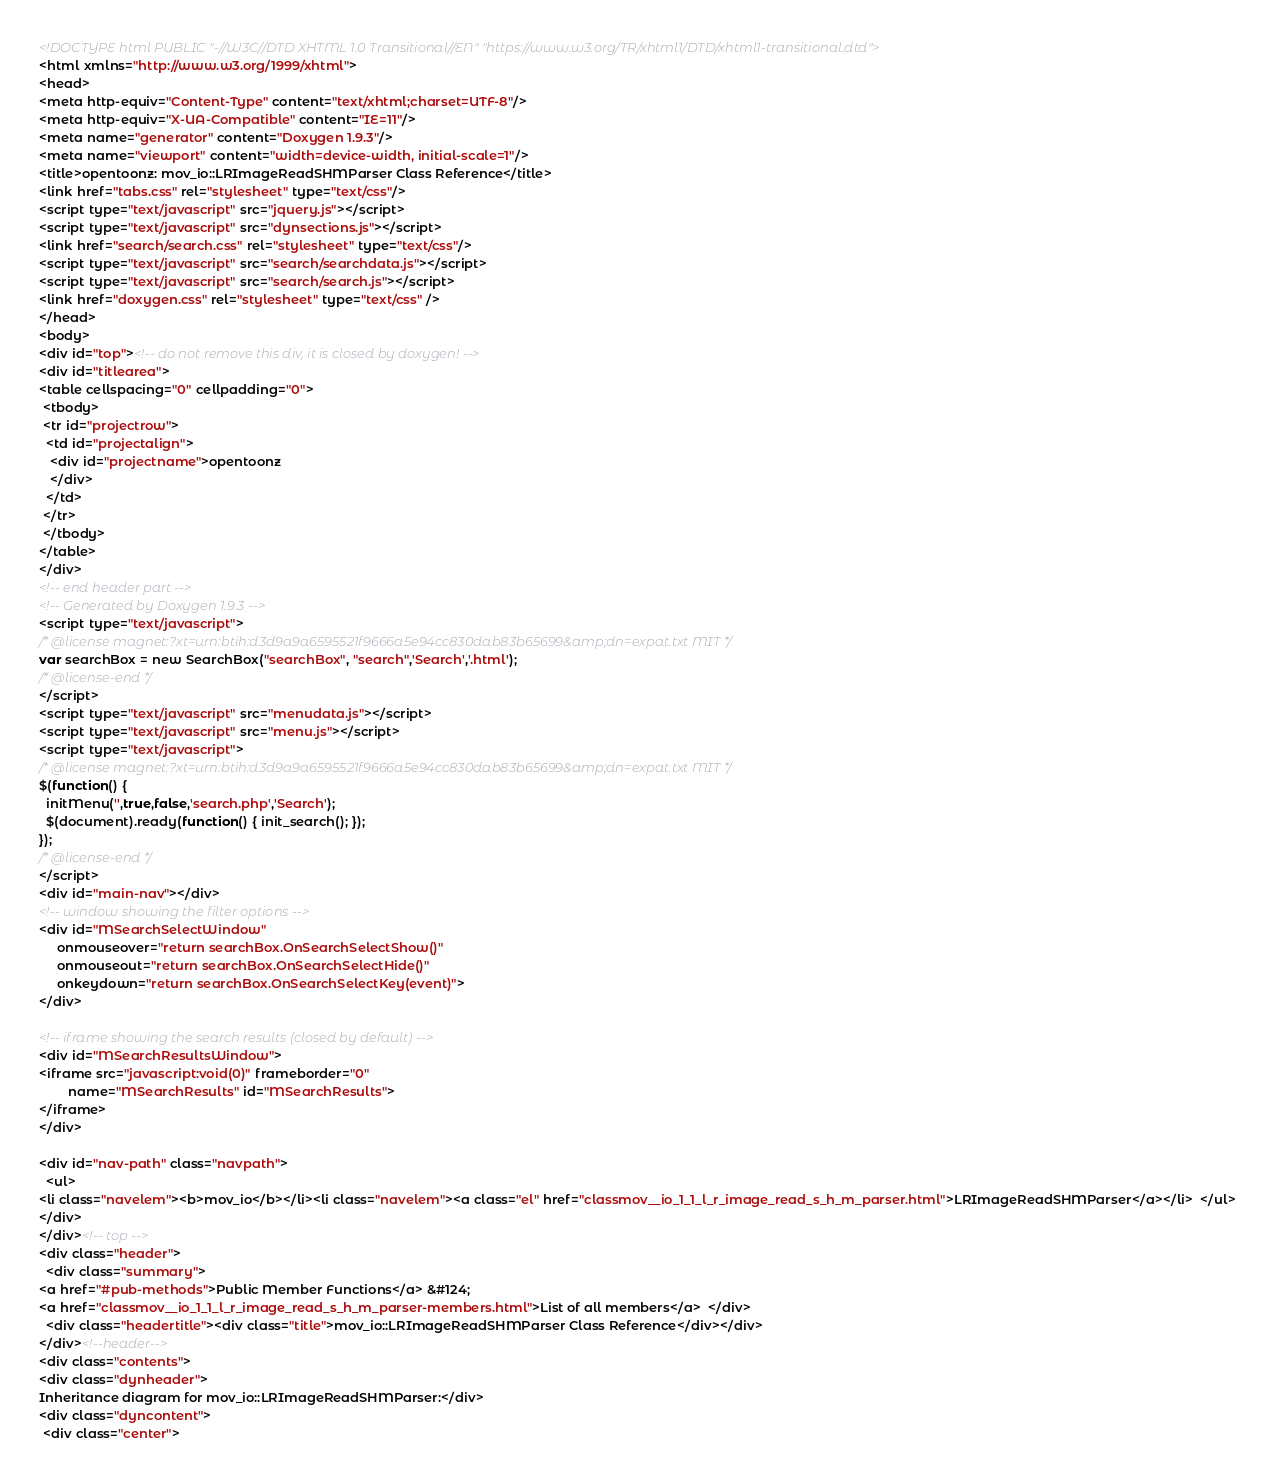Convert code to text. <code><loc_0><loc_0><loc_500><loc_500><_HTML_><!DOCTYPE html PUBLIC "-//W3C//DTD XHTML 1.0 Transitional//EN" "https://www.w3.org/TR/xhtml1/DTD/xhtml1-transitional.dtd">
<html xmlns="http://www.w3.org/1999/xhtml">
<head>
<meta http-equiv="Content-Type" content="text/xhtml;charset=UTF-8"/>
<meta http-equiv="X-UA-Compatible" content="IE=11"/>
<meta name="generator" content="Doxygen 1.9.3"/>
<meta name="viewport" content="width=device-width, initial-scale=1"/>
<title>opentoonz: mov_io::LRImageReadSHMParser Class Reference</title>
<link href="tabs.css" rel="stylesheet" type="text/css"/>
<script type="text/javascript" src="jquery.js"></script>
<script type="text/javascript" src="dynsections.js"></script>
<link href="search/search.css" rel="stylesheet" type="text/css"/>
<script type="text/javascript" src="search/searchdata.js"></script>
<script type="text/javascript" src="search/search.js"></script>
<link href="doxygen.css" rel="stylesheet" type="text/css" />
</head>
<body>
<div id="top"><!-- do not remove this div, it is closed by doxygen! -->
<div id="titlearea">
<table cellspacing="0" cellpadding="0">
 <tbody>
 <tr id="projectrow">
  <td id="projectalign">
   <div id="projectname">opentoonz
   </div>
  </td>
 </tr>
 </tbody>
</table>
</div>
<!-- end header part -->
<!-- Generated by Doxygen 1.9.3 -->
<script type="text/javascript">
/* @license magnet:?xt=urn:btih:d3d9a9a6595521f9666a5e94cc830dab83b65699&amp;dn=expat.txt MIT */
var searchBox = new SearchBox("searchBox", "search",'Search','.html');
/* @license-end */
</script>
<script type="text/javascript" src="menudata.js"></script>
<script type="text/javascript" src="menu.js"></script>
<script type="text/javascript">
/* @license magnet:?xt=urn:btih:d3d9a9a6595521f9666a5e94cc830dab83b65699&amp;dn=expat.txt MIT */
$(function() {
  initMenu('',true,false,'search.php','Search');
  $(document).ready(function() { init_search(); });
});
/* @license-end */
</script>
<div id="main-nav"></div>
<!-- window showing the filter options -->
<div id="MSearchSelectWindow"
     onmouseover="return searchBox.OnSearchSelectShow()"
     onmouseout="return searchBox.OnSearchSelectHide()"
     onkeydown="return searchBox.OnSearchSelectKey(event)">
</div>

<!-- iframe showing the search results (closed by default) -->
<div id="MSearchResultsWindow">
<iframe src="javascript:void(0)" frameborder="0" 
        name="MSearchResults" id="MSearchResults">
</iframe>
</div>

<div id="nav-path" class="navpath">
  <ul>
<li class="navelem"><b>mov_io</b></li><li class="navelem"><a class="el" href="classmov__io_1_1_l_r_image_read_s_h_m_parser.html">LRImageReadSHMParser</a></li>  </ul>
</div>
</div><!-- top -->
<div class="header">
  <div class="summary">
<a href="#pub-methods">Public Member Functions</a> &#124;
<a href="classmov__io_1_1_l_r_image_read_s_h_m_parser-members.html">List of all members</a>  </div>
  <div class="headertitle"><div class="title">mov_io::LRImageReadSHMParser Class Reference</div></div>
</div><!--header-->
<div class="contents">
<div class="dynheader">
Inheritance diagram for mov_io::LRImageReadSHMParser:</div>
<div class="dyncontent">
 <div class="center"></code> 